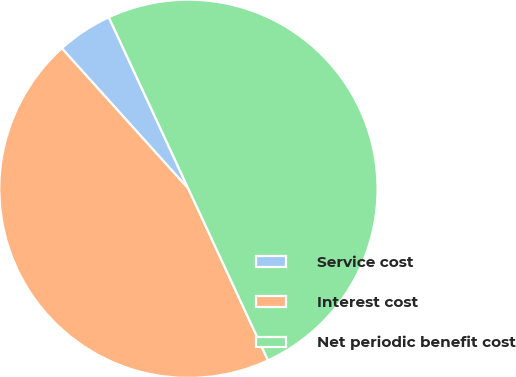<chart> <loc_0><loc_0><loc_500><loc_500><pie_chart><fcel>Service cost<fcel>Interest cost<fcel>Net periodic benefit cost<nl><fcel>4.76%<fcel>45.24%<fcel>50.0%<nl></chart> 